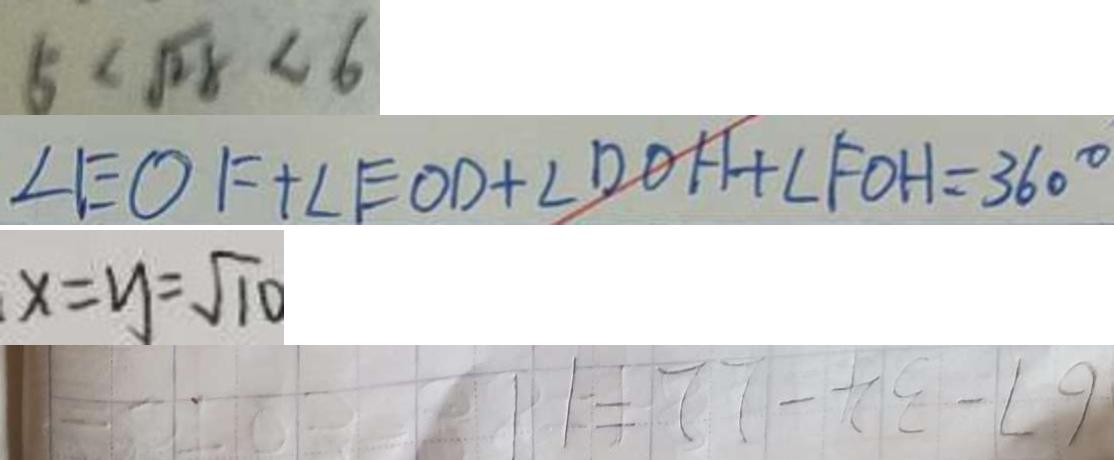<formula> <loc_0><loc_0><loc_500><loc_500>5 < \sqrt { 2 8 } < 6 
 \angle E O F + \angle E O D + \angle D O H + \angle F O H = 3 6 0 ^ { \circ } 
 x = y = \sqrt { 1 0 } 
 6 7 - 3 4 - 2 2 = 1 1</formula> 